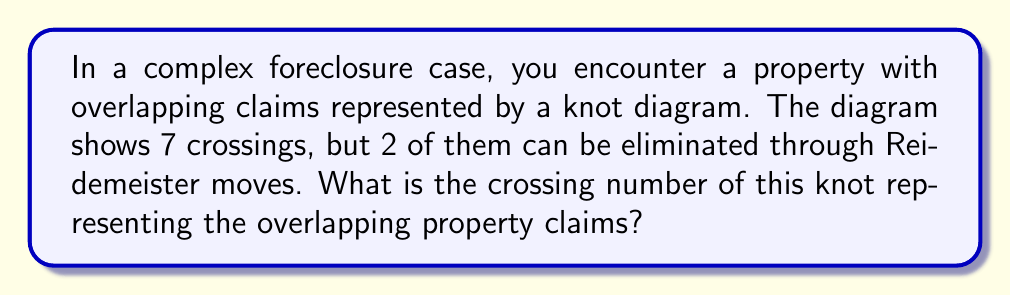Can you solve this math problem? To solve this problem, we need to follow these steps:

1. Understand the concept of crossing number:
   The crossing number of a knot is the minimum number of crossings that occur in any diagram of the knot.

2. Analyze the given information:
   - The initial diagram shows 7 crossings.
   - 2 crossings can be eliminated through Reidemeister moves.

3. Apply Reidemeister moves:
   Reidemeister moves are operations that can be performed on a knot diagram without changing the underlying knot. They can sometimes reduce the number of crossings.

4. Calculate the remaining crossings:
   $$7 \text{ crossings} - 2 \text{ eliminated crossings} = 5 \text{ crossings}$$

5. Determine if this is the minimal crossing number:
   Since we've applied Reidemeister moves to reduce the number of crossings, and no further reductions are mentioned, we can assume this is the minimal representation of the knot.

Therefore, the crossing number of the knot representing the overlapping property claims is 5.
Answer: 5 